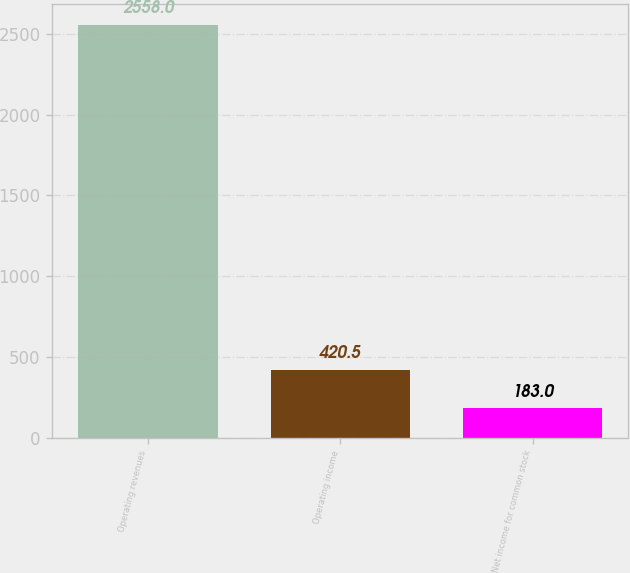<chart> <loc_0><loc_0><loc_500><loc_500><bar_chart><fcel>Operating revenues<fcel>Operating income<fcel>Net income for common stock<nl><fcel>2558<fcel>420.5<fcel>183<nl></chart> 